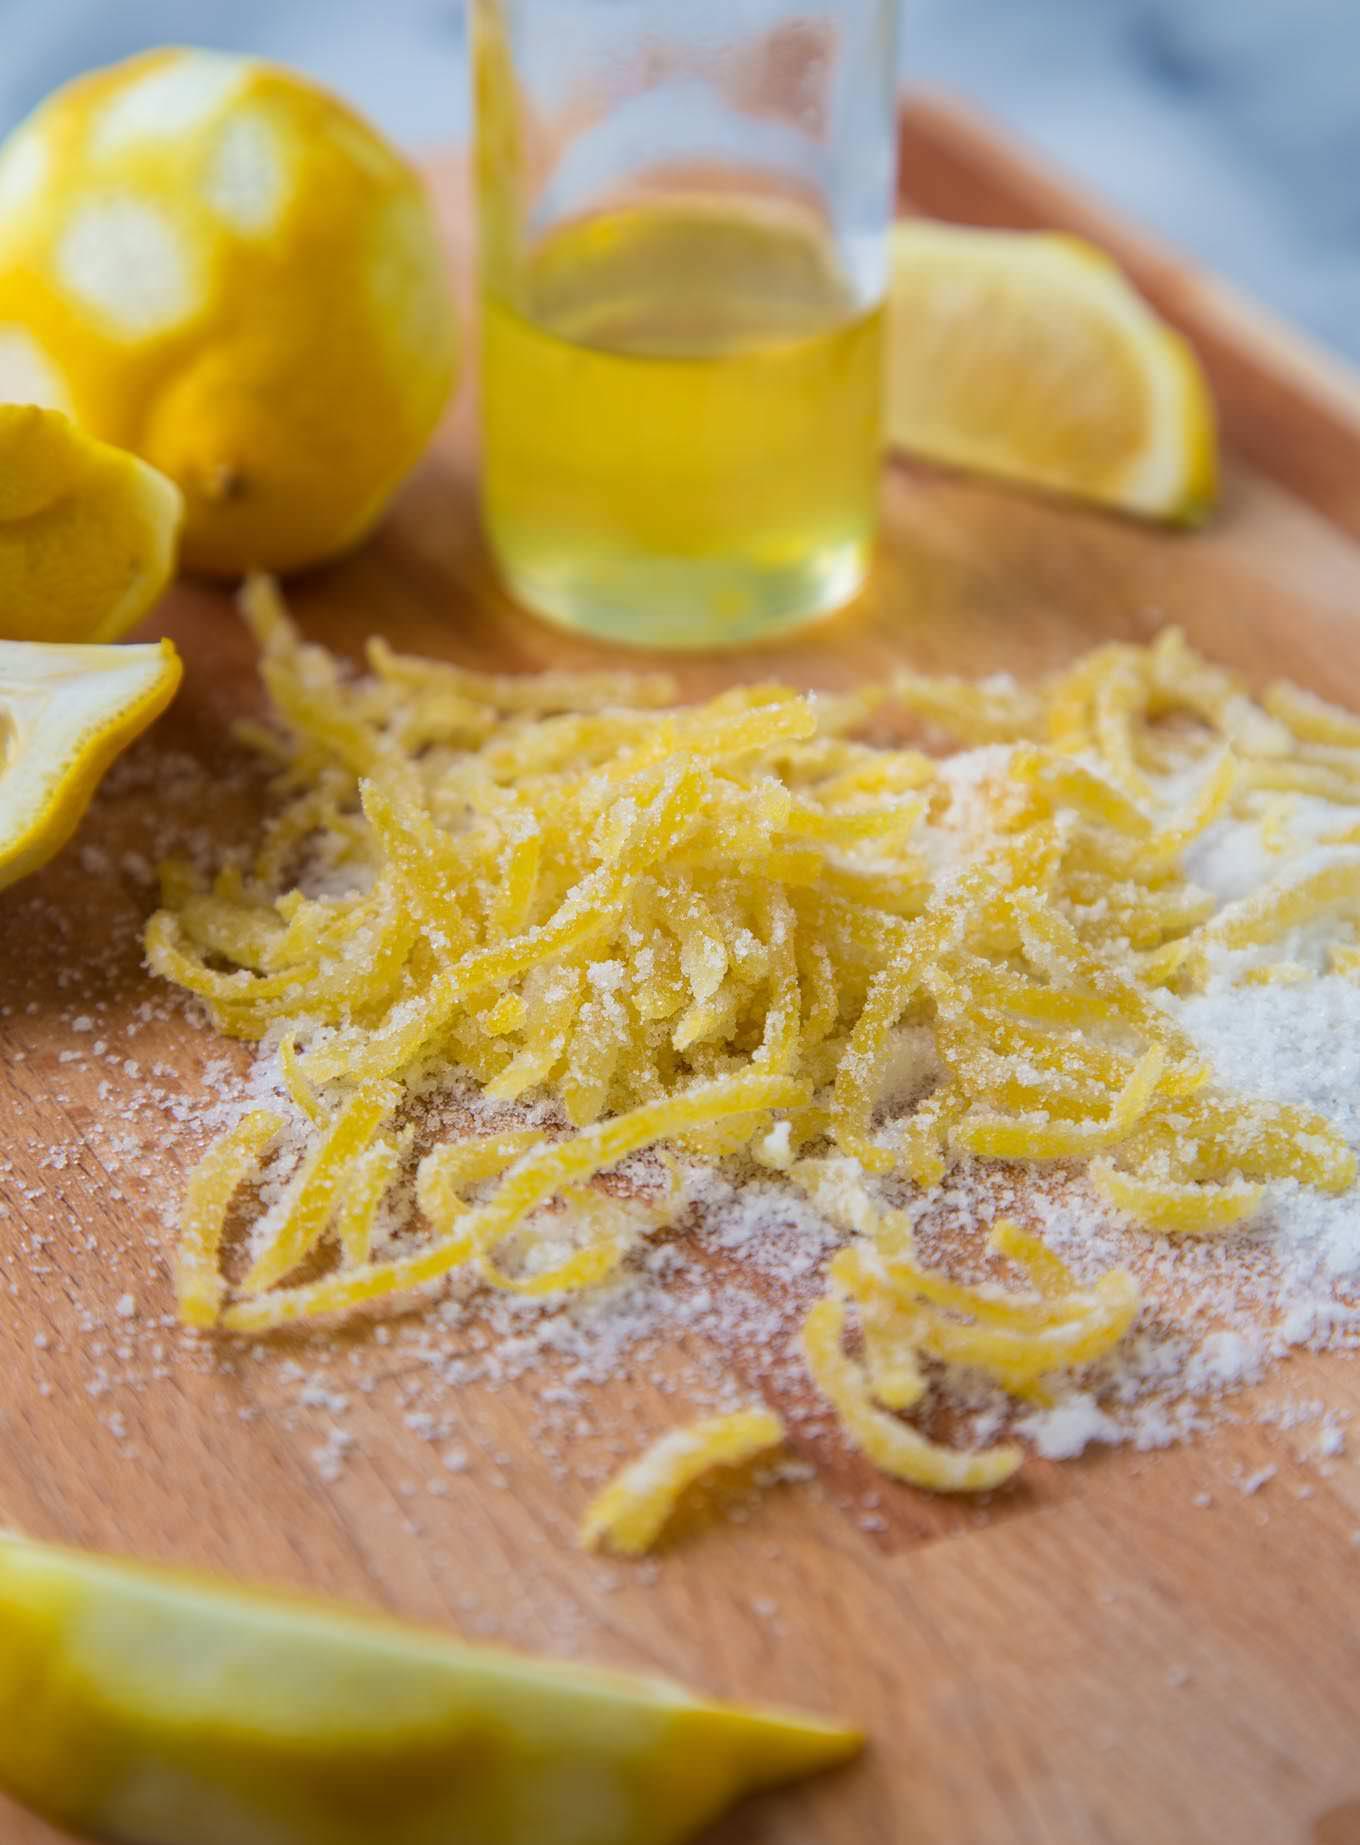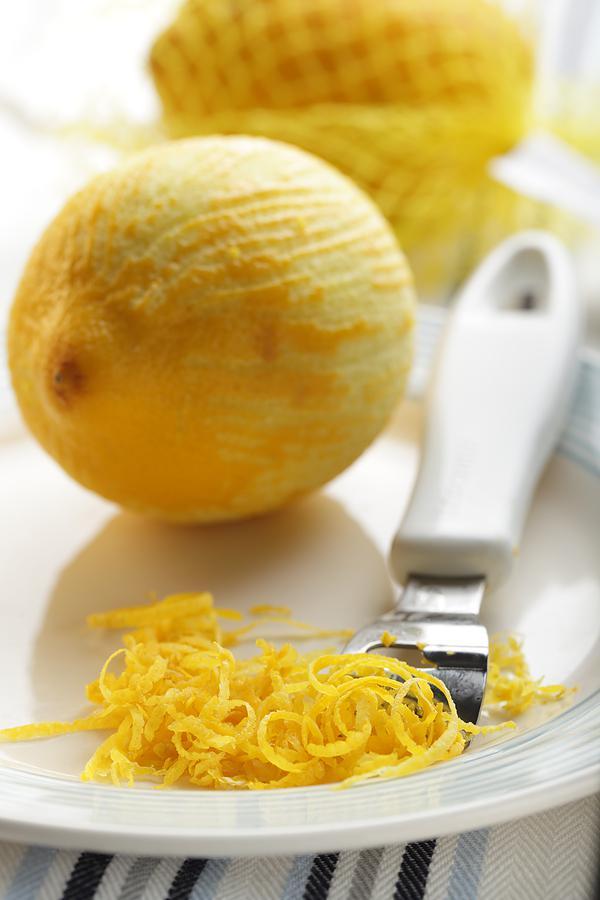The first image is the image on the left, the second image is the image on the right. Examine the images to the left and right. Is the description "A lemon is on a microplane zester and there is a pile of finely shaved lemon zest." accurate? Answer yes or no. No. The first image is the image on the left, the second image is the image on the right. For the images shown, is this caption "One lemon is cut in half." true? Answer yes or no. No. 